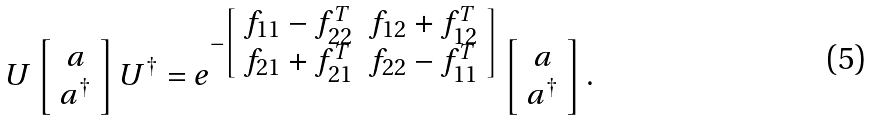<formula> <loc_0><loc_0><loc_500><loc_500>U \left [ \begin{array} { c } a \\ a ^ { \dagger } \end{array} \right ] U ^ { \dagger } = e ^ { - \left [ \begin{array} { c c } f _ { 1 1 } - f _ { 2 2 } ^ { T } & f _ { 1 2 } + f _ { 1 2 } ^ { T } \\ f _ { 2 1 } + f _ { 2 1 } ^ { T } & f _ { 2 2 } - f _ { 1 1 } ^ { T } \end{array} \right ] } \left [ \begin{array} { c } a \\ a ^ { \dagger } \end{array} \right ] .</formula> 